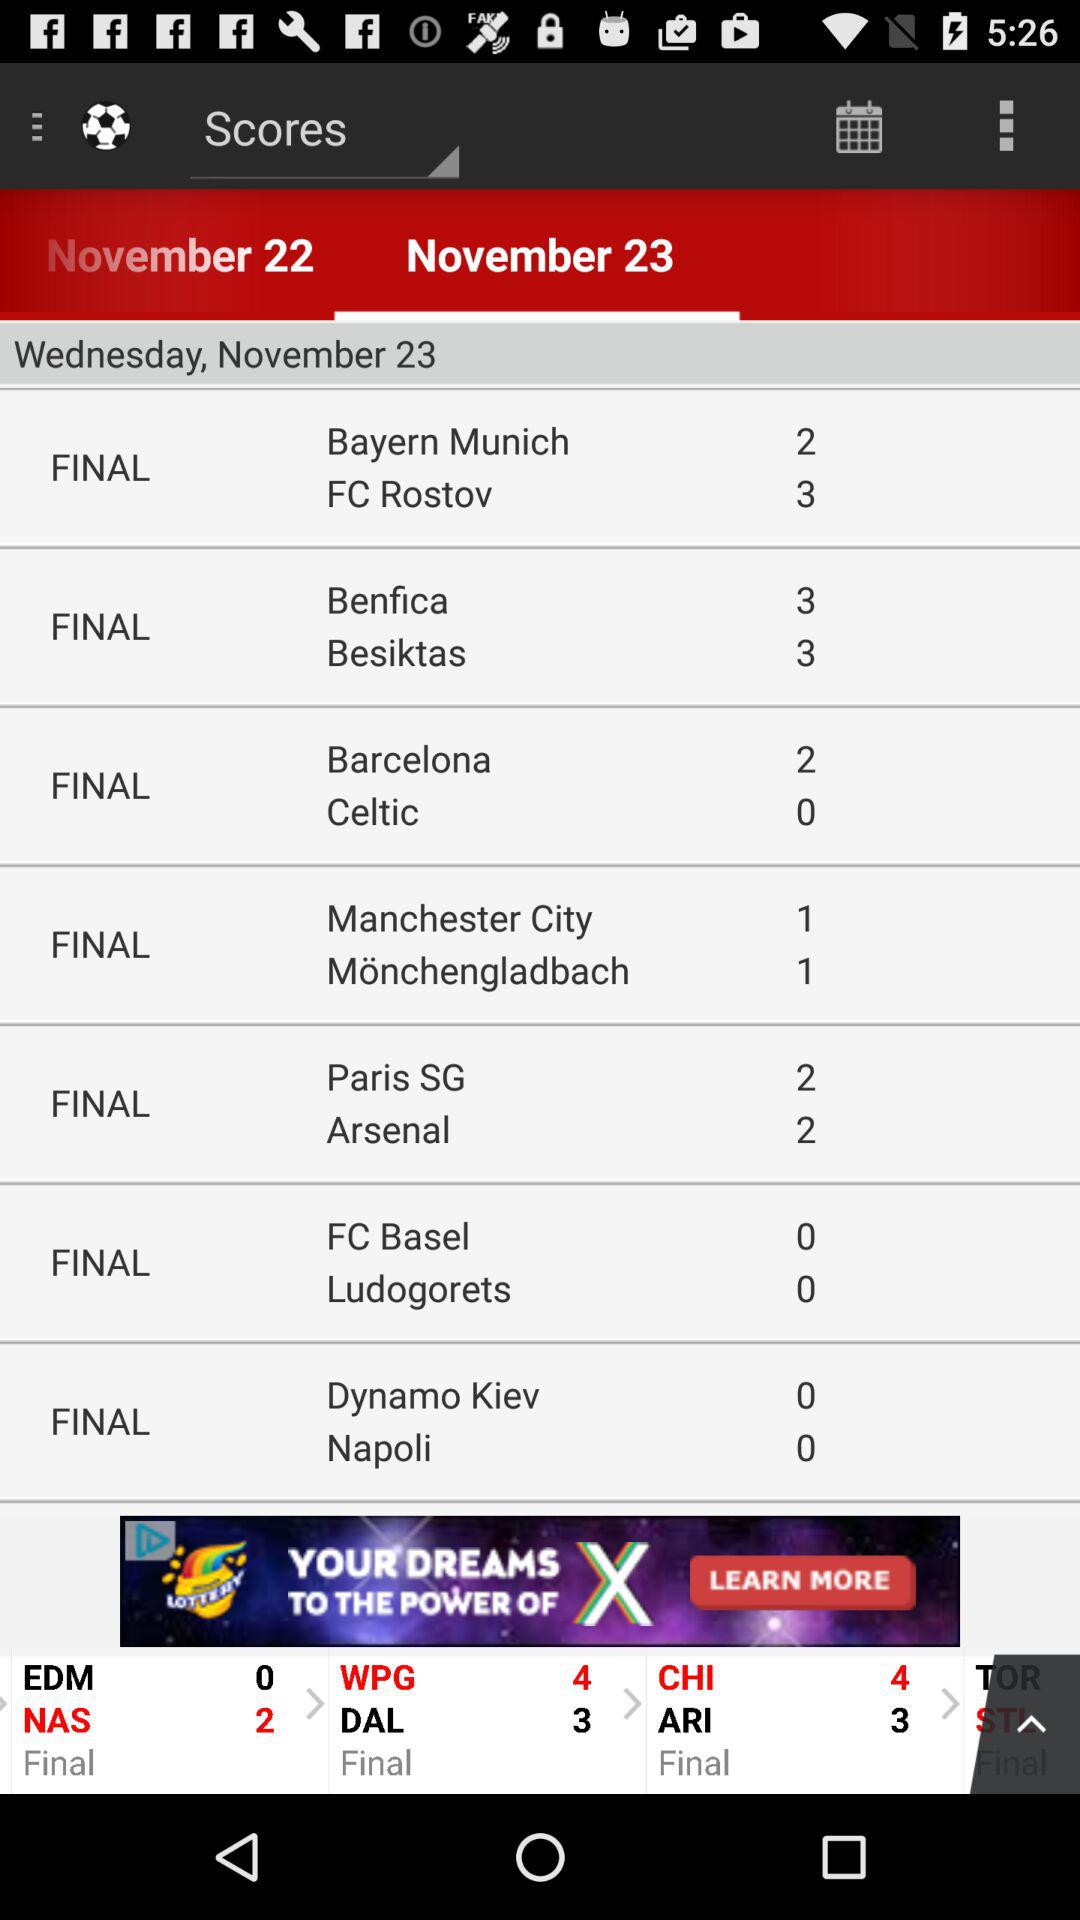What is the score between "EDM" and "NAS"? The score between "EDM" and "NAS" is 0 and 2 respectively. 